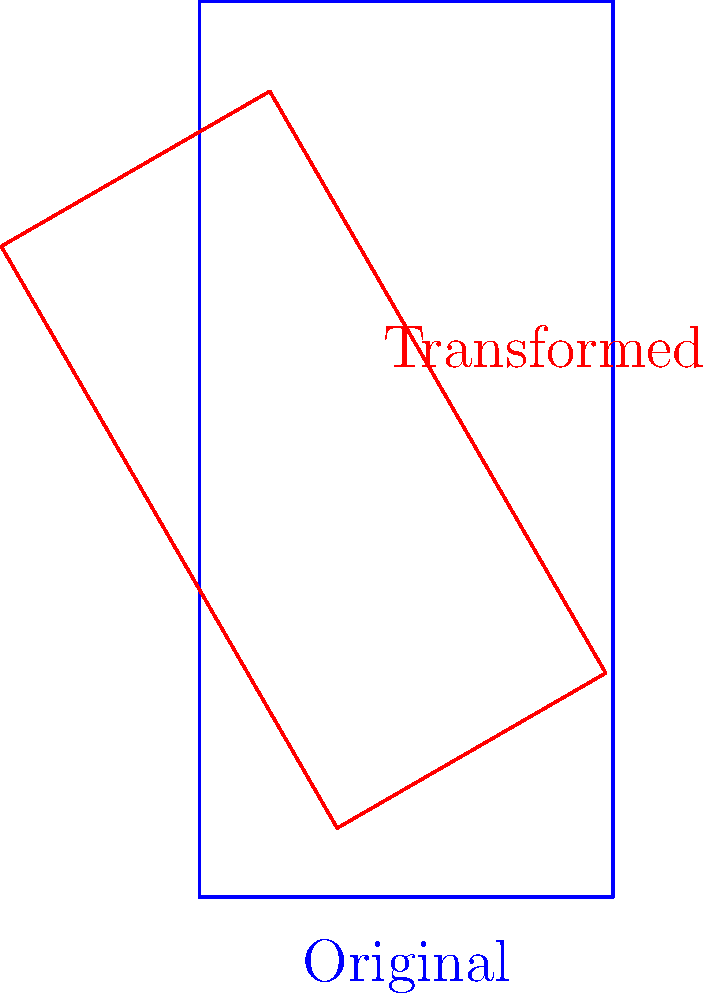A badminton court is represented by a rectangle on a coordinate plane. The court undergoes the following transformations in order:
1. Scaling by a factor of 0.75
2. Rotation by 30° counterclockwise around the origin
3. Translation by 2 units right and 1 unit up

If the original court measures 6 units wide and 13 units long, what is the area of the transformed court? Let's approach this step-by-step:

1) The original area of the court:
   $A_{original} = 6 \times 13 = 78$ square units

2) Scaling by a factor of 0.75:
   This affects the area by a factor of $0.75^2 = 0.5625$
   $A_{scaled} = 78 \times 0.5625 = 43.875$ square units

3) Rotation:
   Rotation doesn't change the area of a shape, so the area remains 43.875 square units.

4) Translation:
   Translation also doesn't change the area of a shape.

Therefore, the final area of the transformed court is 43.875 square units.

Note: The order of transformations is important for the final position and orientation of the court, but in this case, it doesn't affect the final area calculation.
Answer: 43.875 square units 